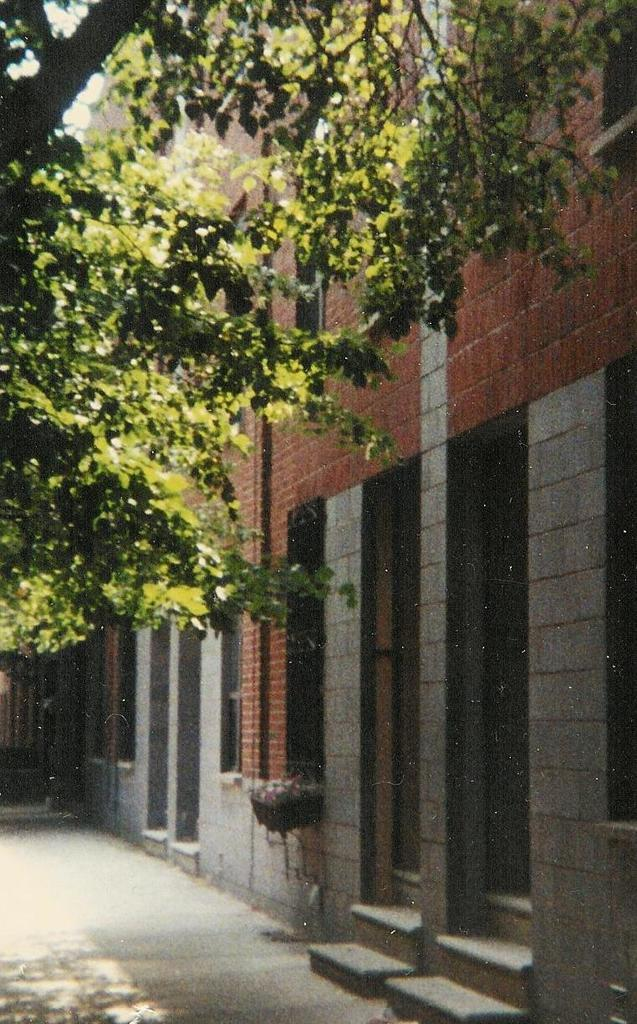What type of structure can be seen in the image? There is a wall in the image. What natural element is present in the image? There is a tree in the image. What can be used for walking or traveling in the image? There is a pathway visible at the bottom portion of the image. What is the weight of the agreement between the tree and the wall in the image? There is no agreement between the tree and the wall in the image, and therefore no weight can be assigned to it. 